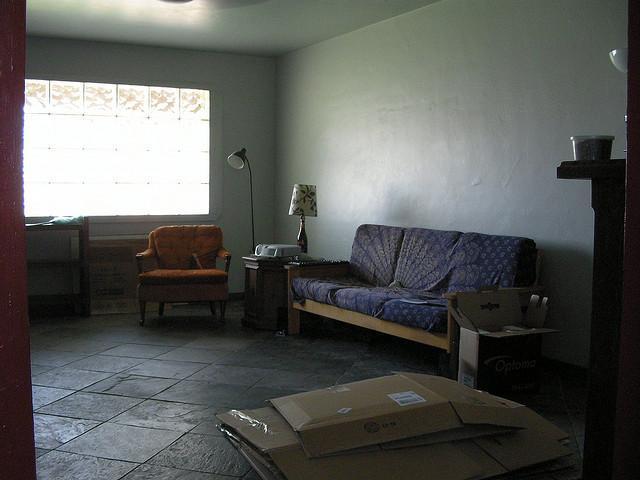How many pillows in the chair on the right?
Give a very brief answer. 0. How many couches are in the picture?
Give a very brief answer. 2. How many people are bending over in the picture?
Give a very brief answer. 0. 